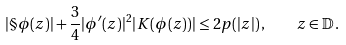Convert formula to latex. <formula><loc_0><loc_0><loc_500><loc_500>| \S \phi ( z ) | + \frac { 3 } { 4 } | \phi ^ { \prime } ( z ) | ^ { 2 } | K ( \phi ( z ) ) | \leq 2 p ( | z | ) \, , \quad z \in \mathbb { D } \, .</formula> 